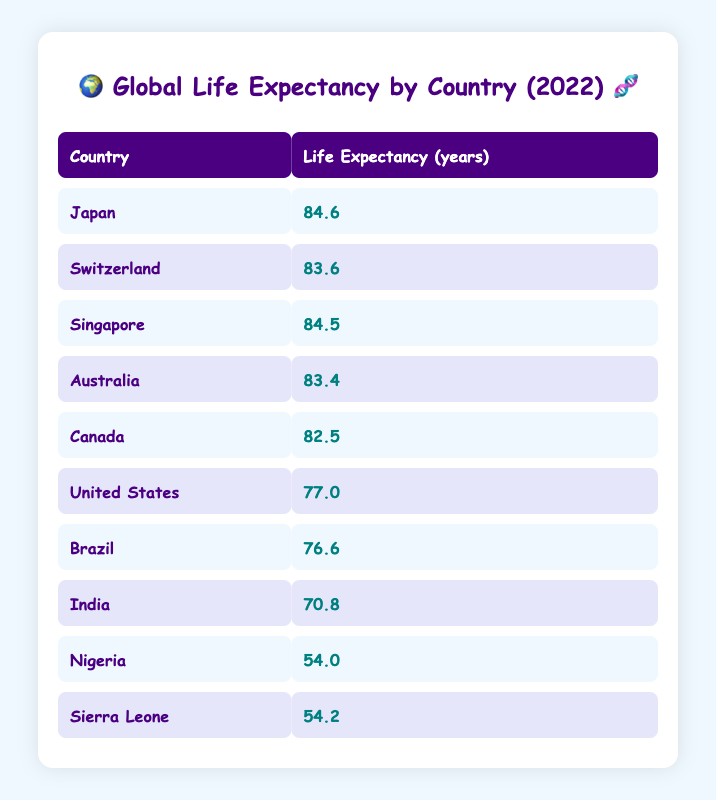What is the life expectancy of Japan? The table lists "Japan" in the country column, and its corresponding life expectancy in the life expectancy column is 84.6 years.
Answer: 84.6 Which country has the lowest life expectancy listed in this table? By examining the life expectancy values in the table, "Nigeria" has the lowest recorded life expectancy at 54.0 years.
Answer: Nigeria Calculate the average life expectancy of the top three countries in the table. The top three countries are Japan (84.6), Singapore (84.5), and Switzerland (83.6). Adding these values gives 84.6 + 84.5 + 83.6 = 252.7. Dividing by 3 yields an average of 252.7/3 = 84.23.
Answer: 84.23 Is the life expectancy of the United States greater than 75 years? The life expectancy of the United States is noted as 77.0 years in the table, which is greater than 75 years.
Answer: Yes Which two countries have a life expectancy closer to each other: Nigeria and Sierra Leone or Japan and Switzerland? Comparing Nigeria (54.0) and Sierra Leone (54.2), the difference is 0.2 years. For Japan (84.6) and Switzerland (83.6), the difference is 1 year. Since 0.2 is smaller than 1, Nigeria and Sierra Leone have life expectancies that are closer to each other.
Answer: Nigeria and Sierra Leone What is the total life expectancy of all countries listed in the table? To find the total, we sum each country's life expectancy: 84.6 + 83.6 + 84.5 + 83.4 + 82.5 + 77.0 + 76.6 + 70.8 + 54.0 + 54.2 =  800.2.
Answer: 800.2 Which country has a life expectancy greater than 80 years and is not in Asia? The countries with life expectancy over 80 years are Japan (not considered here as it's in Asia), Singapore (also in Asia), Switzerland (not in Asia), and Australia (not in Asia). Out of these, Switzerland (83.6) and Australia (83.4) have life expectancies greater than 80 and are not in Asia.
Answer: Switzerland, Australia What is the difference in life expectancy between Brazil and Canada? The life expectancy for Canada is 82.5 years and for Brazil, it is 76.6 years. The difference is 82.5 - 76.6 = 5.9 years.
Answer: 5.9 